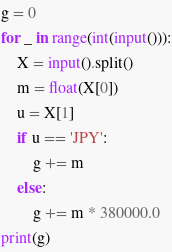Convert code to text. <code><loc_0><loc_0><loc_500><loc_500><_Python_>g = 0
for _ in range(int(input())):
    X = input().split()
    m = float(X[0])
    u = X[1]
    if u == 'JPY':
        g += m
    else:
        g += m * 380000.0
print(g)</code> 